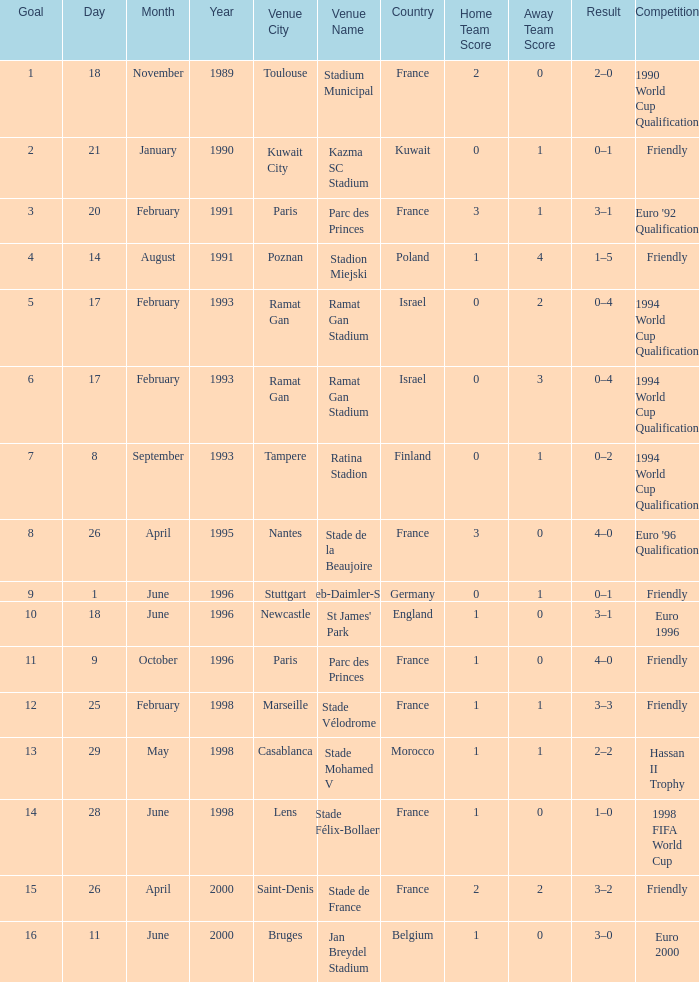What was the date of the game with a goal of 7? 8 September 1993. Could you parse the entire table as a dict? {'header': ['Goal', 'Day', 'Month', 'Year', 'Venue City', 'Venue Name', 'Country', 'Home Team Score', 'Away Team Score', 'Result', 'Competition'], 'rows': [['1', '18', 'November', '1989', 'Toulouse', 'Stadium Municipal', 'France', '2', '0', '2–0', '1990 World Cup Qualification'], ['2', '21', 'January', '1990', 'Kuwait City', 'Kazma SC Stadium', 'Kuwait', '0', '1', '0–1', 'Friendly'], ['3', '20', 'February', '1991', 'Paris', 'Parc des Princes', 'France', '3', '1', '3–1', "Euro '92 Qualification"], ['4', '14', 'August', '1991', 'Poznan', 'Stadion Miejski', 'Poland', '1', '4', '1–5', 'Friendly'], ['5', '17', 'February', '1993', 'Ramat Gan', 'Ramat Gan Stadium', 'Israel', '0', '2', '0–4', '1994 World Cup Qualification'], ['6', '17', 'February', '1993', 'Ramat Gan', 'Ramat Gan Stadium', 'Israel', '0', '3', '0–4', '1994 World Cup Qualification'], ['7', '8', 'September', '1993', 'Tampere', 'Ratina Stadion', 'Finland', '0', '1', '0–2', '1994 World Cup Qualification'], ['8', '26', 'April', '1995', 'Nantes', 'Stade de la Beaujoire', 'France', '3', '0', '4–0', "Euro '96 Qualification"], ['9', '1', 'June', '1996', 'Stuttgart', 'Gottlieb-Daimler-Stadion', 'Germany', '0', '1', '0–1', 'Friendly'], ['10', '18', 'June', '1996', 'Newcastle', "St James' Park", 'England', '1', '0', '3–1', 'Euro 1996'], ['11', '9', 'October', '1996', 'Paris', 'Parc des Princes', 'France', '1', '0', '4–0', 'Friendly'], ['12', '25', 'February', '1998', 'Marseille', 'Stade Vélodrome', 'France', '1', '1', '3–3', 'Friendly'], ['13', '29', 'May', '1998', 'Casablanca', 'Stade Mohamed V', 'Morocco', '1', '1', '2–2', 'Hassan II Trophy'], ['14', '28', 'June', '1998', 'Lens', 'Stade Félix-Bollaert', 'France', '1', '0', '1–0', '1998 FIFA World Cup'], ['15', '26', 'April', '2000', 'Saint-Denis', 'Stade de France', 'France', '2', '2', '3–2', 'Friendly'], ['16', '11', 'June', '2000', 'Bruges', 'Jan Breydel Stadium', 'Belgium', '1', '0', '3–0', 'Euro 2000']]} 